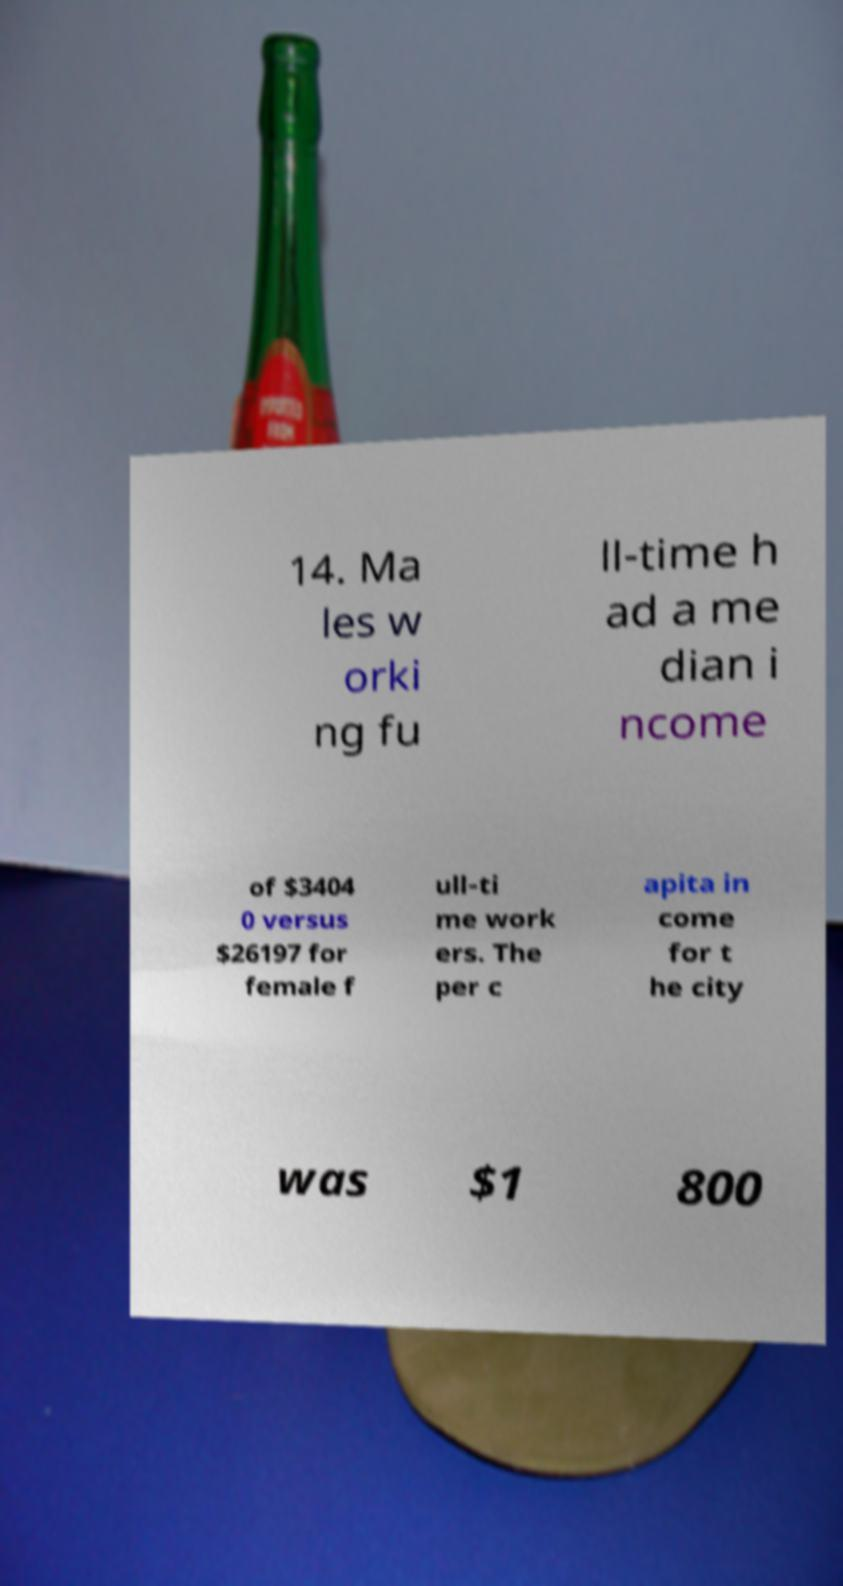Can you read and provide the text displayed in the image?This photo seems to have some interesting text. Can you extract and type it out for me? 14. Ma les w orki ng fu ll-time h ad a me dian i ncome of $3404 0 versus $26197 for female f ull-ti me work ers. The per c apita in come for t he city was $1 800 